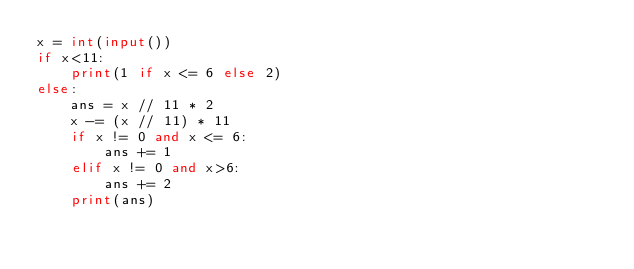<code> <loc_0><loc_0><loc_500><loc_500><_Python_>x = int(input())
if x<11:
    print(1 if x <= 6 else 2)
else:
    ans = x // 11 * 2
    x -= (x // 11) * 11
    if x != 0 and x <= 6:
        ans += 1
    elif x != 0 and x>6:
        ans += 2
    print(ans)</code> 